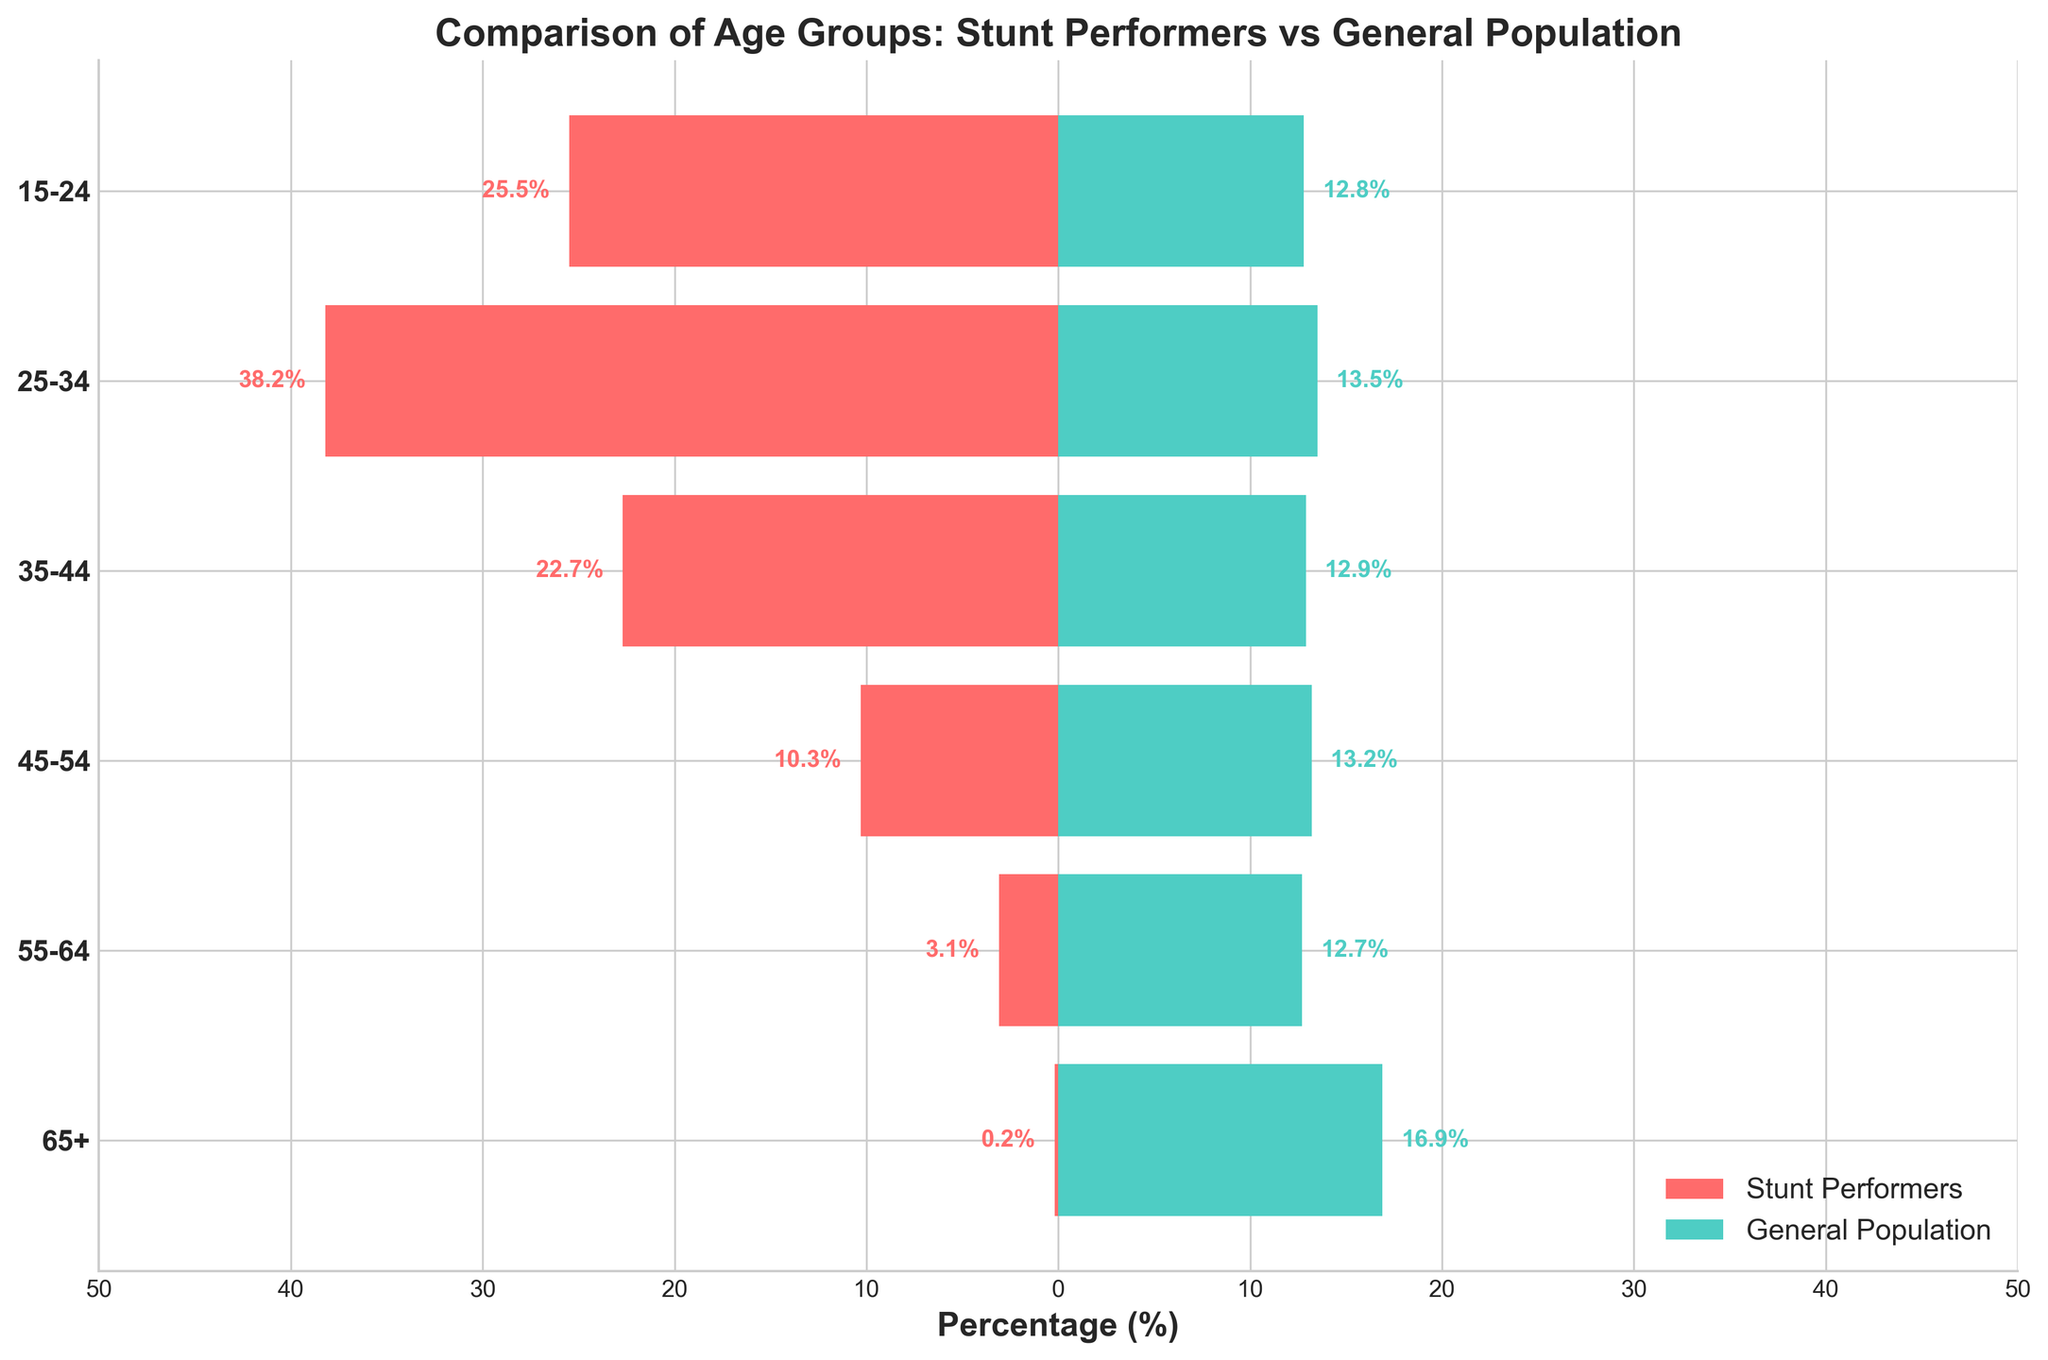What's the percentage of stunt performers in the 25-34 age group? The chart shows the percentage of stunt performers as bars extending to the left. We look for the bar corresponding to the 25-34 age group.
Answer: 38.2% Which age group has the highest percentage of stunt performers? We identify the age group with the longest bar extending to the left. The 25-34 age group has the longest bar for stunt performers.
Answer: 25-34 How does the percentage of the general population aged 65+ compare to that of stunt performers in the same age group? We compare the bars for the 65+ age group on both sides of the chart. The general population has a bar reaching 16.9%, while stunt performers have a very small bar at 0.2%.
Answer: The general population is much higher What is the combined percentage of stunt performers in the 15-24 and 25-34 age groups? Add the percentages of stunt performers in the 15-24 age group (25.5%) and the 25-34 age group (38.2%).
Answer: 63.7% Which age group has a higher percentage in the general population compared to stunt performers? Look for age groups where the bar extending to the right is longer than the one extending to the left. For instance, the 55-64 age group where the general population is at 12.7% while stunt performers are at 3.1%.
Answer: 55-64 What is the average percentage of general population within the age groups under 45? Sum the percentages of the general population in the 15-24 (12.8%), 25-34 (13.5%), and 35-44 (12.9%) age groups and divide by 3. (12.8 + 13.5 + 12.9) / 3 = 13.07
Answer: 13.07% In which age group do both categories (stunt performers and general population) have almost equal percentages? Look for age groups where the bars have similar lengths on both sides. For instance, the 45-54 age group shows stunt performers at 10.3% and the general population at 13.2%. Though not equal, they are closer compared to other groups.
Answer: 45-54 (closest) How does the percentage of stunt performers in the 35-44 age group compare to that in the 55-64 age group? Compare the lengths of the bars for these age groups. The percentage of stunt performers in the 35-44 age group (22.7%) is significantly higher than that in the 55-64 age group (3.1%).
Answer: 35-44 age group is higher What is the total percentage of stunt performers aged 45 and above? Add the percentages for the 45-54 (10.3%), 55-64 (3.1%), and 65+ (0.2%) age groups. (10.3 + 3.1 + 0.2) = 13.6%
Answer: 13.6% Is there any age group where stunt performers make up more than 20%? Look for stunt performer bars that are longer than 20% across all age groups. Both the 15-24 (25.5%) and 25-34 (38.2%) age groups meet this criterion.
Answer: Yes, 15-24 and 25-34 